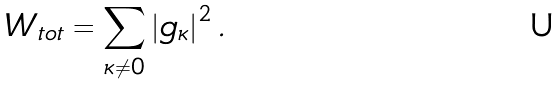<formula> <loc_0><loc_0><loc_500><loc_500>W _ { t o t } = \sum _ { \kappa \neq 0 } \left | g _ { \kappa } \right | ^ { 2 } .</formula> 